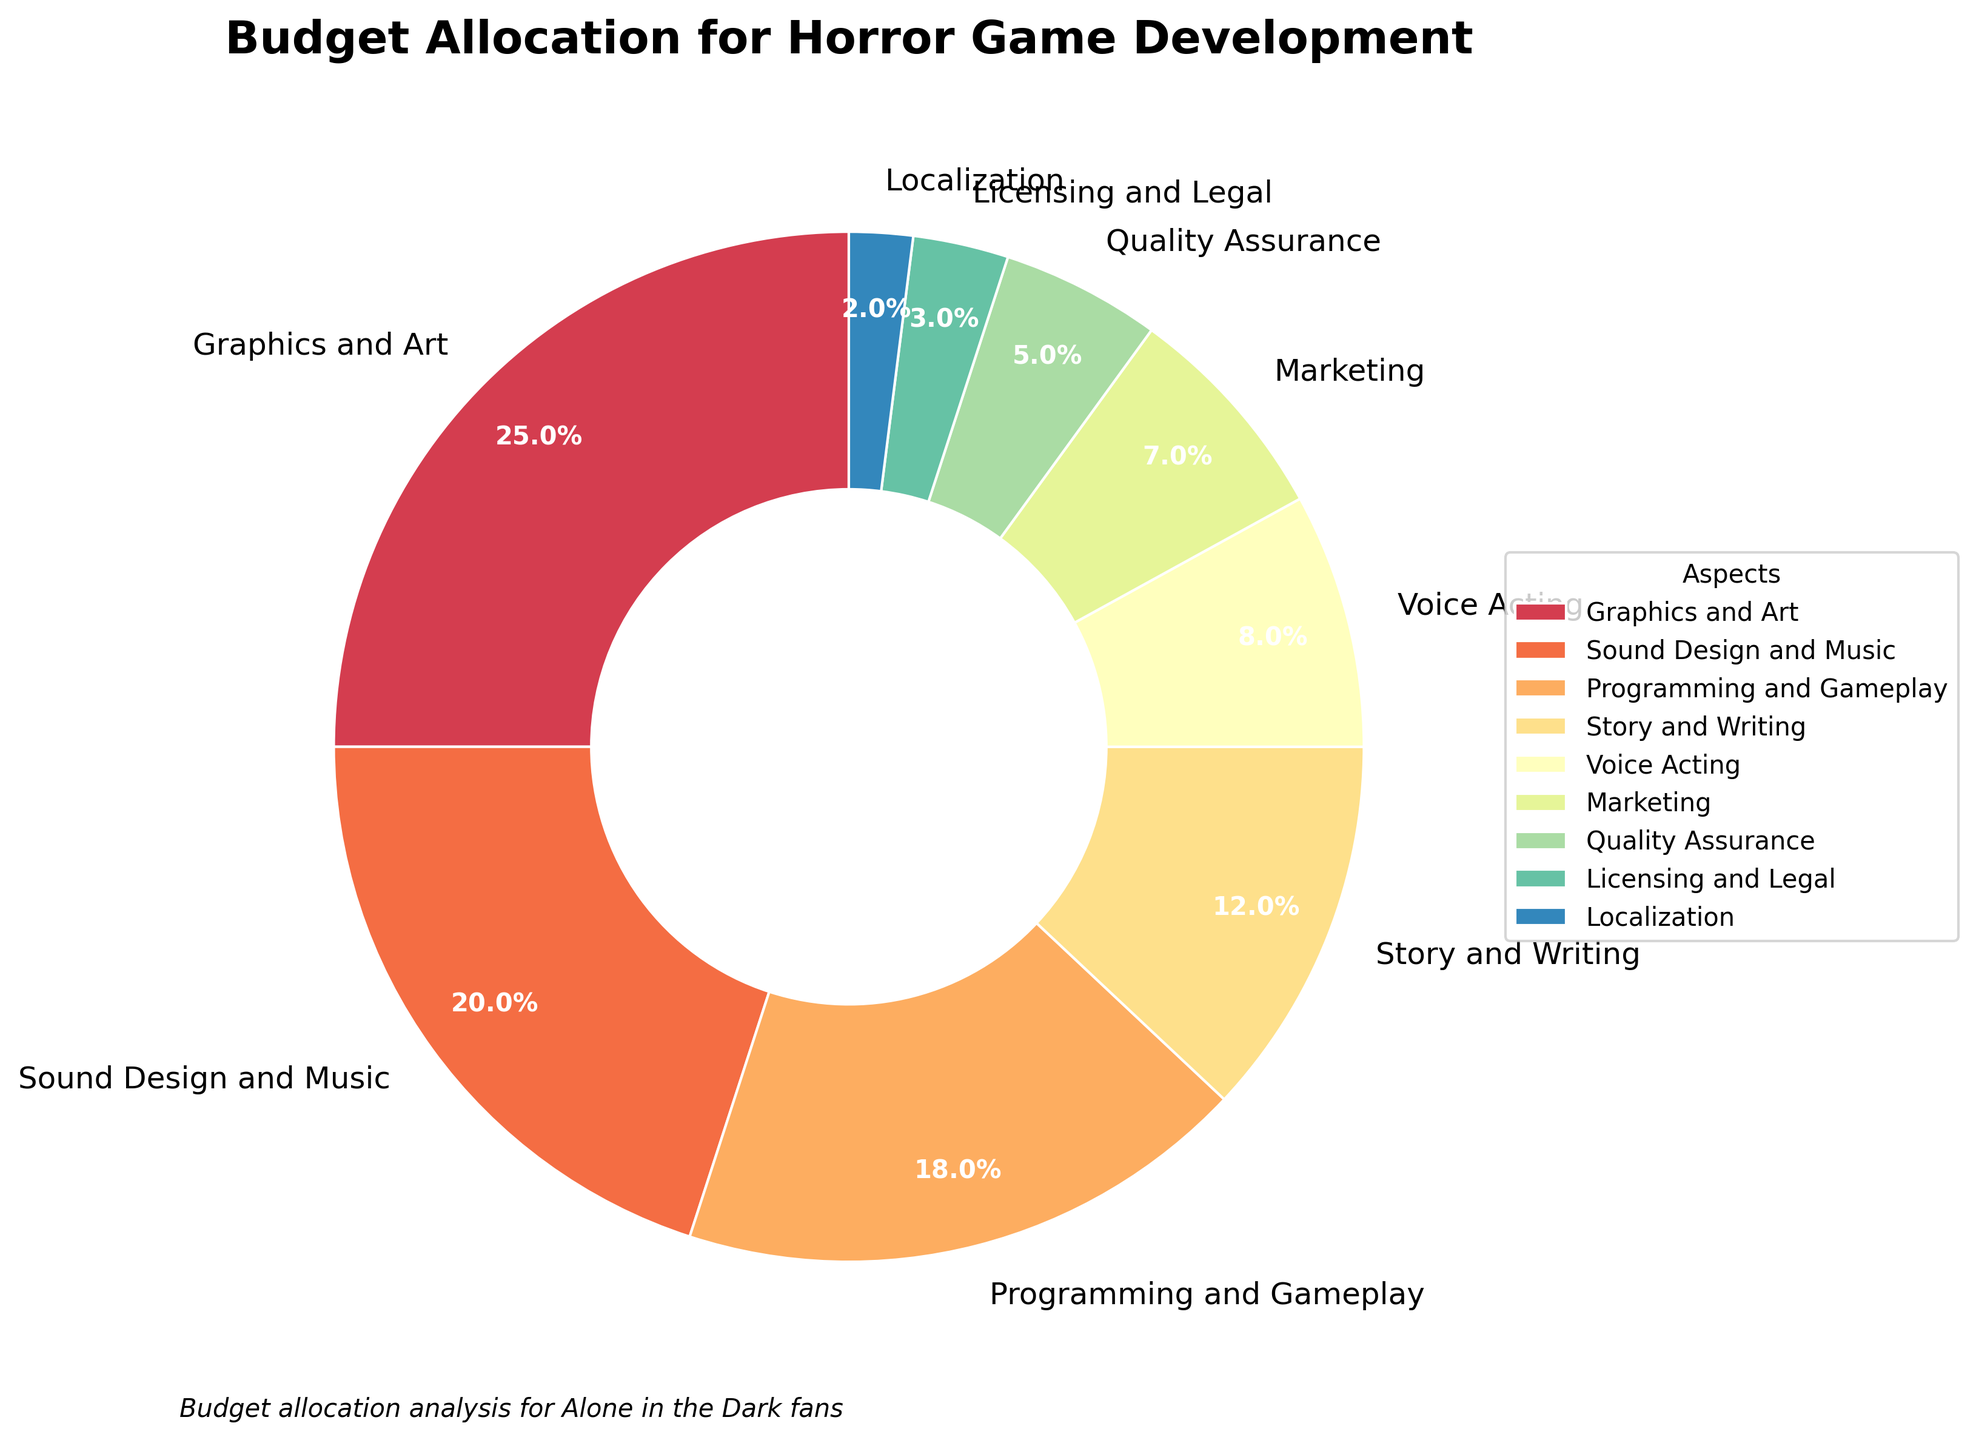What percentage of the budget is allocated to Sound Design and Music? Sound Design and Music is labeled on the pie chart with the percentage next to it.
Answer: 20% Which aspect has the highest budget allocation? By examining the pie chart, the segment labeled "Graphics and Art" occupies the largest area.
Answer: Graphics and Art How much more budget is allocated to Story and Writing compared to Licensing and Legal? Story and Writing is at 12% while Licensing and Legal is at 3%. The difference is 12% - 3%.
Answer: 9% Which aspect has a smaller budget, Marketing or Quality Assurance? Compare the pie chart segments for Marketing (7%) and Quality Assurance (5%).
Answer: Quality Assurance Sum the budget allocations for Voice Acting, Quality Assurance, and Localization. Add the percentages for Voice Acting (8%), Quality Assurance (5%), and Localization (2%). This results in 8% + 5% + 2%.
Answer: 15% Is the budget allocated to Programming and Gameplay greater than that allocated to Marketing and Localization combined? Programming and Gameplay has an 18% allocation. Marketing (7%) and Localization (2%) combined are 7% + 2% = 9%. 18% is greater than 9%.
Answer: Yes How does the budget for Voice Acting compare to that for Licensing and Legal? Voice Acting has an 8% allocation, while Licensing and Legal has a 3% allocation. 8% is greater than 3%.
Answer: Voice Acting has a higher budget Which aspect has the smallest budget allocation? The pie chart shows Localization with the smallest segment, labeled 2%.
Answer: Localization What percentage of the budget is allocated to aspects directly related to game development (sum of Graphics and Art, Sound Design and Music, Programming and Gameplay, and Story and Writing)? Add the percentages of Graphics and Art (25%), Sound Design and Music (20%), Programming and Gameplay (18%), and Story and Writing (12%), resulting in 25% + 20% + 18% + 12%.
Answer: 75% What is the combined budget allocation for Marketing and Quality Assurance? Add the percentages allocated to Marketing (7%) and Quality Assurance (5%), resulting in 7% + 5%.
Answer: 12% 